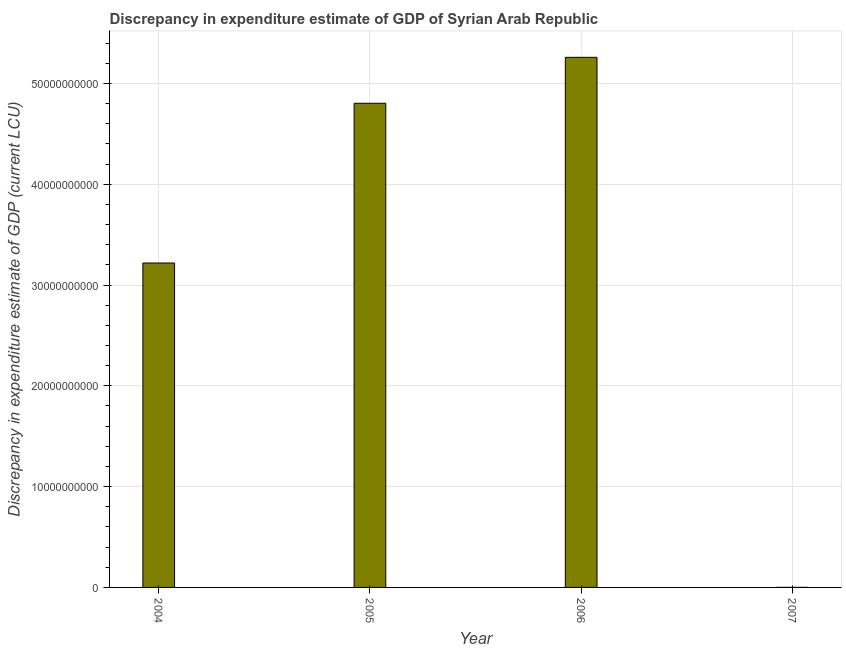What is the title of the graph?
Give a very brief answer. Discrepancy in expenditure estimate of GDP of Syrian Arab Republic. What is the label or title of the Y-axis?
Provide a short and direct response. Discrepancy in expenditure estimate of GDP (current LCU). What is the discrepancy in expenditure estimate of gdp in 2007?
Provide a short and direct response. 5.25e+06. Across all years, what is the maximum discrepancy in expenditure estimate of gdp?
Ensure brevity in your answer.  5.26e+1. Across all years, what is the minimum discrepancy in expenditure estimate of gdp?
Provide a short and direct response. 5.25e+06. In which year was the discrepancy in expenditure estimate of gdp maximum?
Make the answer very short. 2006. What is the sum of the discrepancy in expenditure estimate of gdp?
Your response must be concise. 1.33e+11. What is the difference between the discrepancy in expenditure estimate of gdp in 2005 and 2007?
Your answer should be very brief. 4.80e+1. What is the average discrepancy in expenditure estimate of gdp per year?
Make the answer very short. 3.32e+1. What is the median discrepancy in expenditure estimate of gdp?
Provide a short and direct response. 4.01e+1. What is the ratio of the discrepancy in expenditure estimate of gdp in 2005 to that in 2007?
Provide a short and direct response. 9149.77. What is the difference between the highest and the second highest discrepancy in expenditure estimate of gdp?
Offer a very short reply. 4.56e+09. Is the sum of the discrepancy in expenditure estimate of gdp in 2006 and 2007 greater than the maximum discrepancy in expenditure estimate of gdp across all years?
Provide a succinct answer. Yes. What is the difference between the highest and the lowest discrepancy in expenditure estimate of gdp?
Provide a short and direct response. 5.26e+1. In how many years, is the discrepancy in expenditure estimate of gdp greater than the average discrepancy in expenditure estimate of gdp taken over all years?
Your response must be concise. 2. Are all the bars in the graph horizontal?
Keep it short and to the point. No. How many years are there in the graph?
Your response must be concise. 4. Are the values on the major ticks of Y-axis written in scientific E-notation?
Provide a short and direct response. No. What is the Discrepancy in expenditure estimate of GDP (current LCU) of 2004?
Your answer should be very brief. 3.22e+1. What is the Discrepancy in expenditure estimate of GDP (current LCU) of 2005?
Provide a short and direct response. 4.80e+1. What is the Discrepancy in expenditure estimate of GDP (current LCU) of 2006?
Provide a short and direct response. 5.26e+1. What is the Discrepancy in expenditure estimate of GDP (current LCU) in 2007?
Keep it short and to the point. 5.25e+06. What is the difference between the Discrepancy in expenditure estimate of GDP (current LCU) in 2004 and 2005?
Give a very brief answer. -1.58e+1. What is the difference between the Discrepancy in expenditure estimate of GDP (current LCU) in 2004 and 2006?
Provide a short and direct response. -2.04e+1. What is the difference between the Discrepancy in expenditure estimate of GDP (current LCU) in 2004 and 2007?
Your answer should be compact. 3.22e+1. What is the difference between the Discrepancy in expenditure estimate of GDP (current LCU) in 2005 and 2006?
Your response must be concise. -4.56e+09. What is the difference between the Discrepancy in expenditure estimate of GDP (current LCU) in 2005 and 2007?
Ensure brevity in your answer.  4.80e+1. What is the difference between the Discrepancy in expenditure estimate of GDP (current LCU) in 2006 and 2007?
Ensure brevity in your answer.  5.26e+1. What is the ratio of the Discrepancy in expenditure estimate of GDP (current LCU) in 2004 to that in 2005?
Keep it short and to the point. 0.67. What is the ratio of the Discrepancy in expenditure estimate of GDP (current LCU) in 2004 to that in 2006?
Provide a succinct answer. 0.61. What is the ratio of the Discrepancy in expenditure estimate of GDP (current LCU) in 2004 to that in 2007?
Your answer should be very brief. 6131.25. What is the ratio of the Discrepancy in expenditure estimate of GDP (current LCU) in 2005 to that in 2007?
Offer a terse response. 9149.77. What is the ratio of the Discrepancy in expenditure estimate of GDP (current LCU) in 2006 to that in 2007?
Keep it short and to the point. 1.00e+04. 